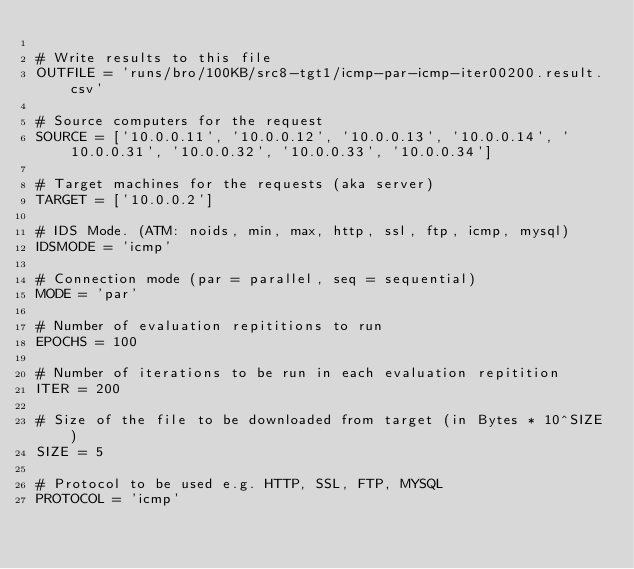Convert code to text. <code><loc_0><loc_0><loc_500><loc_500><_Python_>
# Write results to this file
OUTFILE = 'runs/bro/100KB/src8-tgt1/icmp-par-icmp-iter00200.result.csv'

# Source computers for the request
SOURCE = ['10.0.0.11', '10.0.0.12', '10.0.0.13', '10.0.0.14', '10.0.0.31', '10.0.0.32', '10.0.0.33', '10.0.0.34']

# Target machines for the requests (aka server)
TARGET = ['10.0.0.2']

# IDS Mode. (ATM: noids, min, max, http, ssl, ftp, icmp, mysql)
IDSMODE = 'icmp'

# Connection mode (par = parallel, seq = sequential)
MODE = 'par'

# Number of evaluation repititions to run
EPOCHS = 100

# Number of iterations to be run in each evaluation repitition
ITER = 200

# Size of the file to be downloaded from target (in Bytes * 10^SIZE)
SIZE = 5

# Protocol to be used e.g. HTTP, SSL, FTP, MYSQL
PROTOCOL = 'icmp'</code> 